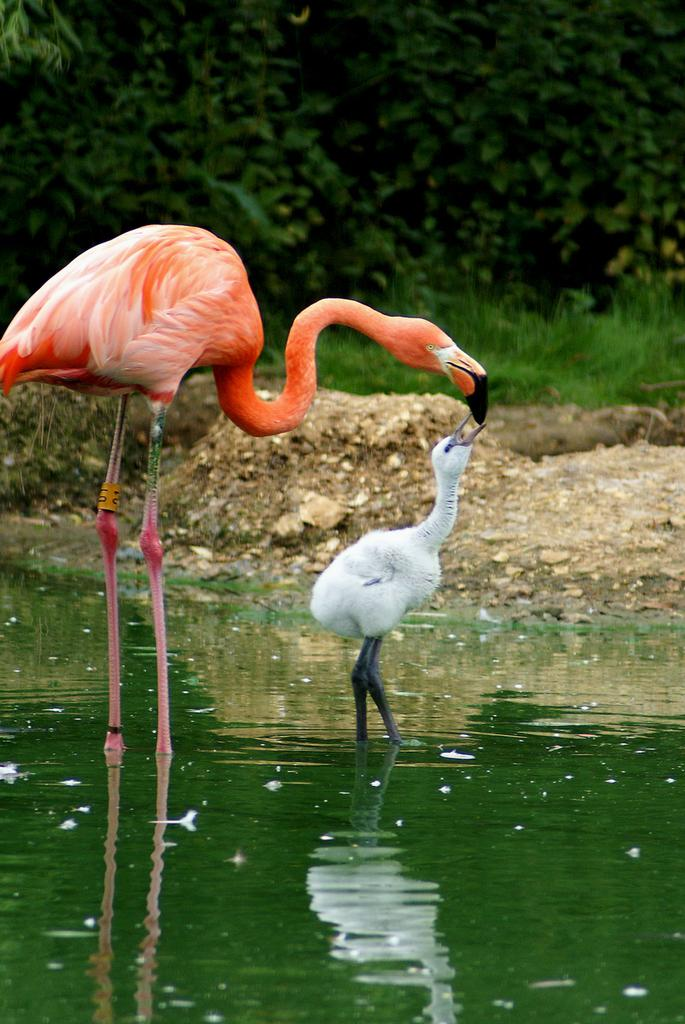How many birds are in the image? There are two birds in the image. What colors are the birds? The birds are orange, black, and white in color. Where are the birds located in the image? The birds are in the water. What can be seen in the background of the image? There are trees and the ground visible in the background of the image. What type of faucet can be seen in the image? There is no faucet present in the image; it features two birds in the water with trees and the ground visible in the background. 